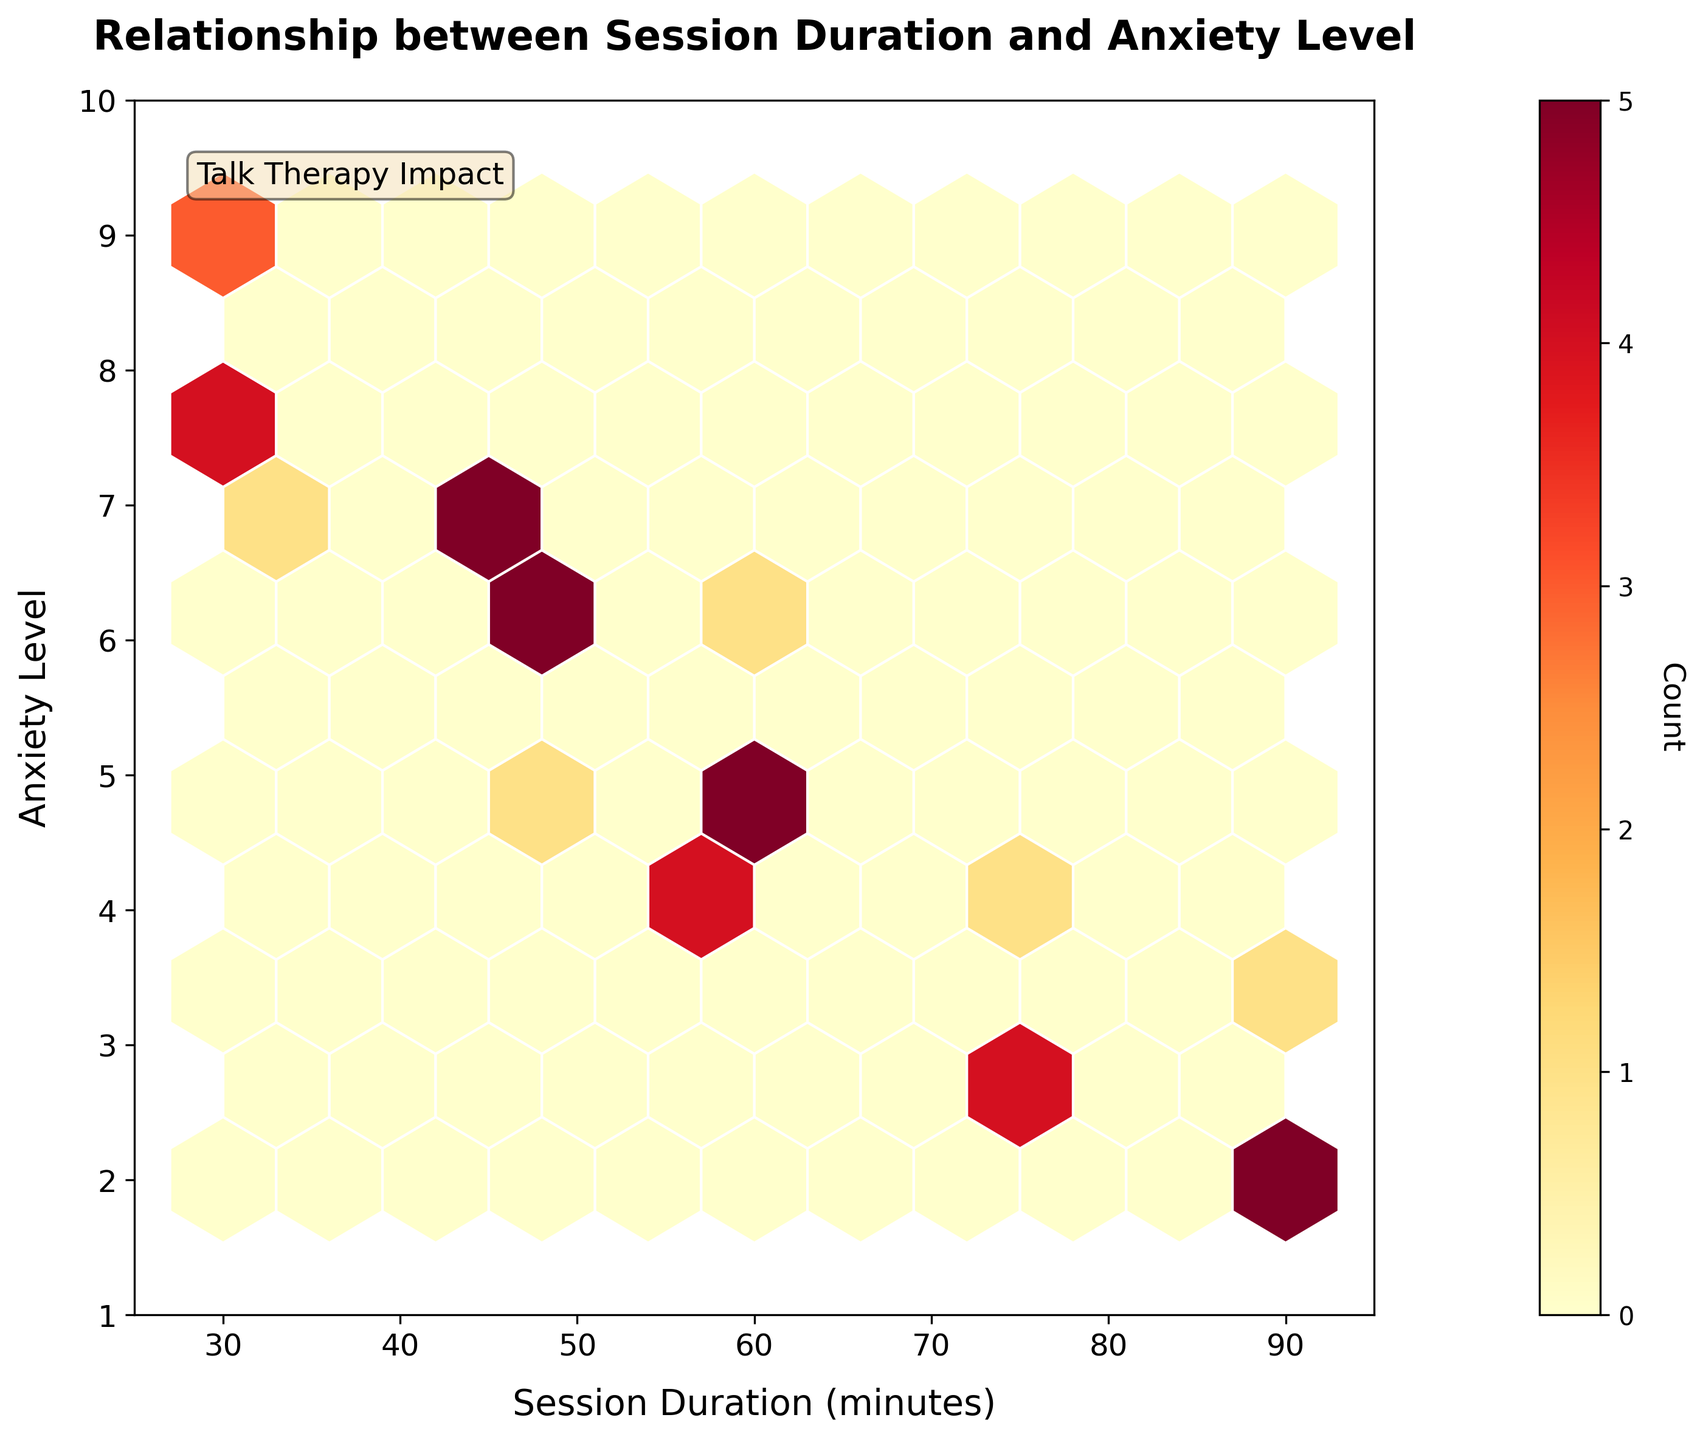What is the title of the figure? The title is prominently displayed at the top of the figure, which indicates the overall theme or subject of the plot.
Answer: Relationship between Session Duration and Anxiety Level What does the color of the hexagons represent? The color of the hexagons shows the count of data points within each hexagonal bin, with the color range indicating the number of overlapping points in that area.
Answer: Count of data points What are the ranges for the axes? By looking at the labels and the ticks on the axes, you can identify the ranges. The x-axis covers session duration from 25 to 95 minutes, and the y-axis ranges from anxiety levels 1 to 10.
Answer: Session Duration: 25 to 95 minutes, Anxiety Level: 1 to 10 What does the concentration of darker hexagons around specific durations and anxiety levels tell you? Darker hexagons indicate regions with more data points. A concentration of dark hexagons near certain session durations and anxiety levels suggests that there is a higher frequency of those specific combinations in the dataset.
Answer: Higher frequency of combinations in those regions At which session duration and anxiety level do we see the highest concentration of sessions? The highest concentration is found by identifying the darkest hexagon on the plot. The plot suggests that the highest concentration occurs around 45 minutes for session duration and an anxiety level of around 6.
Answer: 45 minutes and anxiety level 6 Do shorter sessions correlate with higher reported anxiety levels? Observing the trend in the plot, one can see that higher anxiety levels (closer to 10) are more frequent at shorter session durations (closer to 30 minutes), indicating a potential negative correlation where shorter sessions are often associated with higher anxiety levels.
Answer: Yes What is the relationship between session durations of 60 minutes and anxiety levels? Observing the distribution and density of hexagons around the 60-minute mark on the x-axis, it is clear that sessions of this duration cover a wide range of anxiety levels, generally from 2 to 6.
Answer: Wide range of anxiety levels, generally 2 to 6 Which session duration seems to be most effective in reducing anxiety based on lower reported anxiety levels? By identifying the region where anxiety levels are lower and concentrating towards specific session durations, it can be seen that sessions around 90 minutes are associated with lower anxiety levels, often below 3.
Answer: 90 minutes Is there a session duration where the anxiety levels are consistently high? By observing where hexagons with higher anxiety levels are concentrated, it can be seen that sessions around 30 minutes frequently correspond to higher anxiety levels (7 and above).
Answer: 30 minutes 